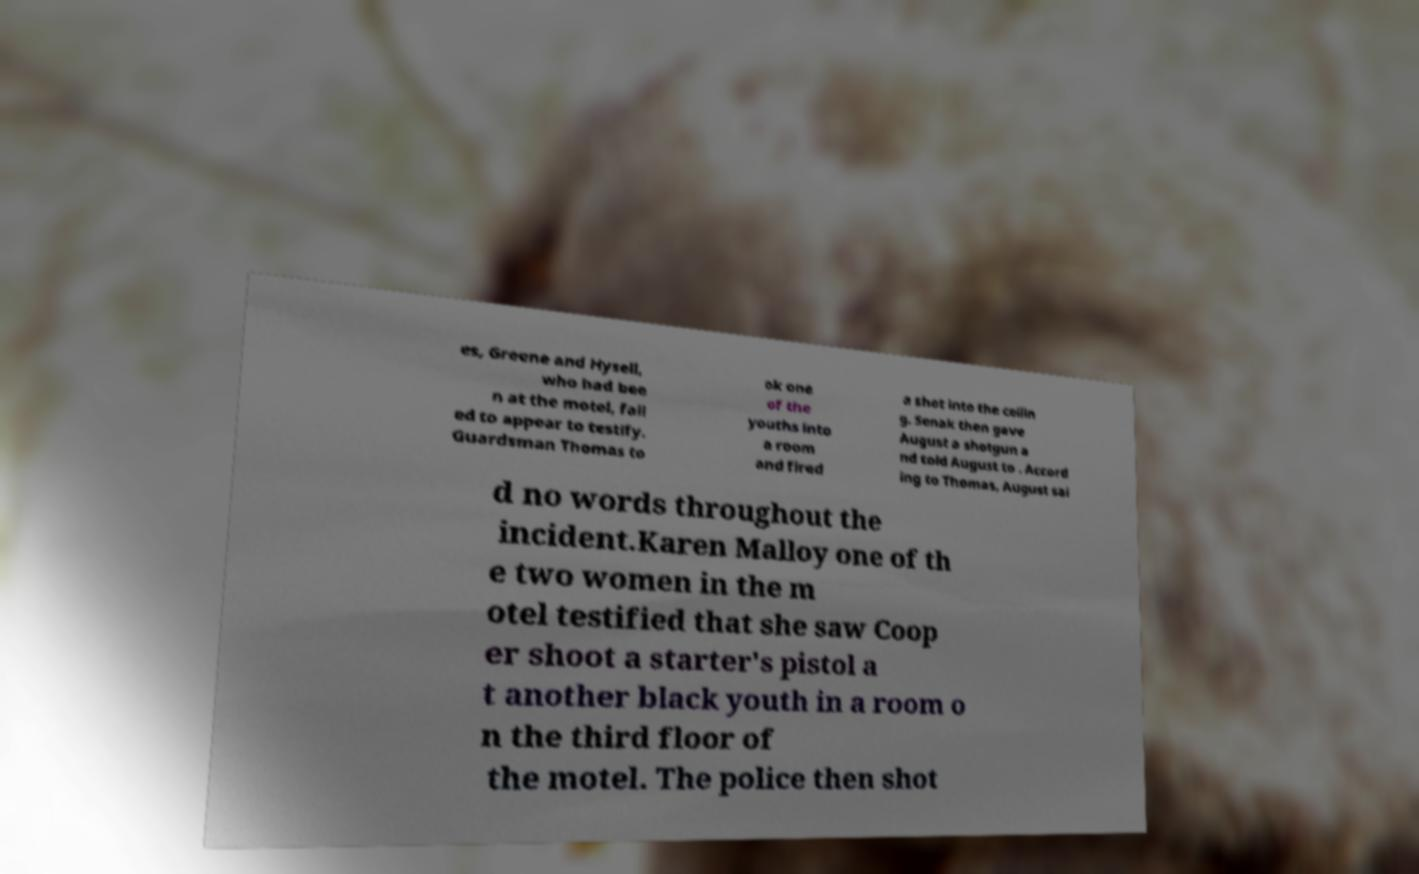I need the written content from this picture converted into text. Can you do that? es, Greene and Hysell, who had bee n at the motel, fail ed to appear to testify. Guardsman Thomas to ok one of the youths into a room and fired a shot into the ceilin g. Senak then gave August a shotgun a nd told August to . Accord ing to Thomas, August sai d no words throughout the incident.Karen Malloy one of th e two women in the m otel testified that she saw Coop er shoot a starter's pistol a t another black youth in a room o n the third floor of the motel. The police then shot 